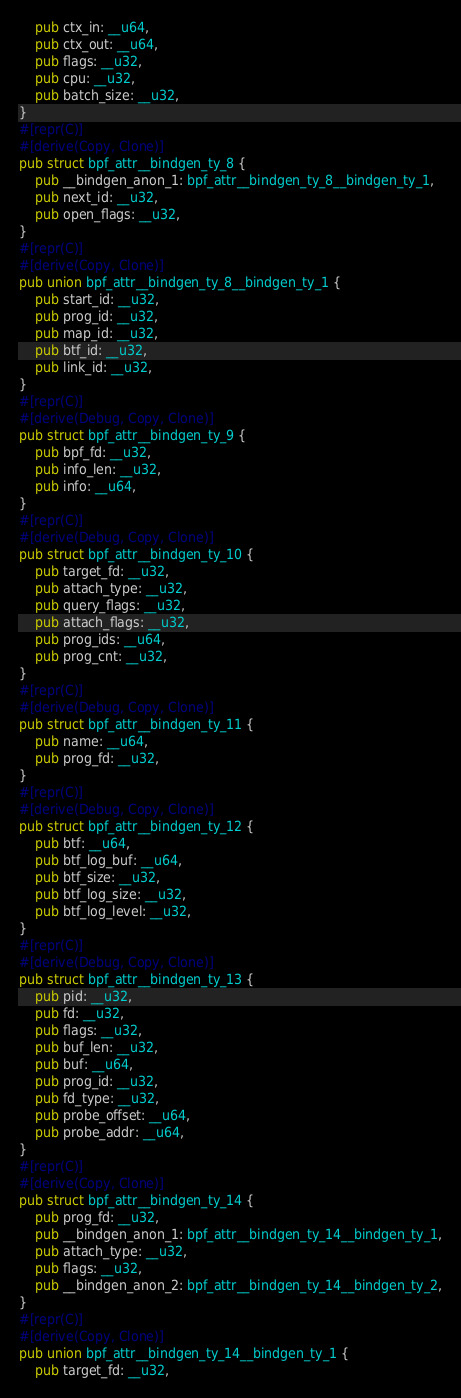<code> <loc_0><loc_0><loc_500><loc_500><_Rust_>    pub ctx_in: __u64,
    pub ctx_out: __u64,
    pub flags: __u32,
    pub cpu: __u32,
    pub batch_size: __u32,
}
#[repr(C)]
#[derive(Copy, Clone)]
pub struct bpf_attr__bindgen_ty_8 {
    pub __bindgen_anon_1: bpf_attr__bindgen_ty_8__bindgen_ty_1,
    pub next_id: __u32,
    pub open_flags: __u32,
}
#[repr(C)]
#[derive(Copy, Clone)]
pub union bpf_attr__bindgen_ty_8__bindgen_ty_1 {
    pub start_id: __u32,
    pub prog_id: __u32,
    pub map_id: __u32,
    pub btf_id: __u32,
    pub link_id: __u32,
}
#[repr(C)]
#[derive(Debug, Copy, Clone)]
pub struct bpf_attr__bindgen_ty_9 {
    pub bpf_fd: __u32,
    pub info_len: __u32,
    pub info: __u64,
}
#[repr(C)]
#[derive(Debug, Copy, Clone)]
pub struct bpf_attr__bindgen_ty_10 {
    pub target_fd: __u32,
    pub attach_type: __u32,
    pub query_flags: __u32,
    pub attach_flags: __u32,
    pub prog_ids: __u64,
    pub prog_cnt: __u32,
}
#[repr(C)]
#[derive(Debug, Copy, Clone)]
pub struct bpf_attr__bindgen_ty_11 {
    pub name: __u64,
    pub prog_fd: __u32,
}
#[repr(C)]
#[derive(Debug, Copy, Clone)]
pub struct bpf_attr__bindgen_ty_12 {
    pub btf: __u64,
    pub btf_log_buf: __u64,
    pub btf_size: __u32,
    pub btf_log_size: __u32,
    pub btf_log_level: __u32,
}
#[repr(C)]
#[derive(Debug, Copy, Clone)]
pub struct bpf_attr__bindgen_ty_13 {
    pub pid: __u32,
    pub fd: __u32,
    pub flags: __u32,
    pub buf_len: __u32,
    pub buf: __u64,
    pub prog_id: __u32,
    pub fd_type: __u32,
    pub probe_offset: __u64,
    pub probe_addr: __u64,
}
#[repr(C)]
#[derive(Copy, Clone)]
pub struct bpf_attr__bindgen_ty_14 {
    pub prog_fd: __u32,
    pub __bindgen_anon_1: bpf_attr__bindgen_ty_14__bindgen_ty_1,
    pub attach_type: __u32,
    pub flags: __u32,
    pub __bindgen_anon_2: bpf_attr__bindgen_ty_14__bindgen_ty_2,
}
#[repr(C)]
#[derive(Copy, Clone)]
pub union bpf_attr__bindgen_ty_14__bindgen_ty_1 {
    pub target_fd: __u32,</code> 